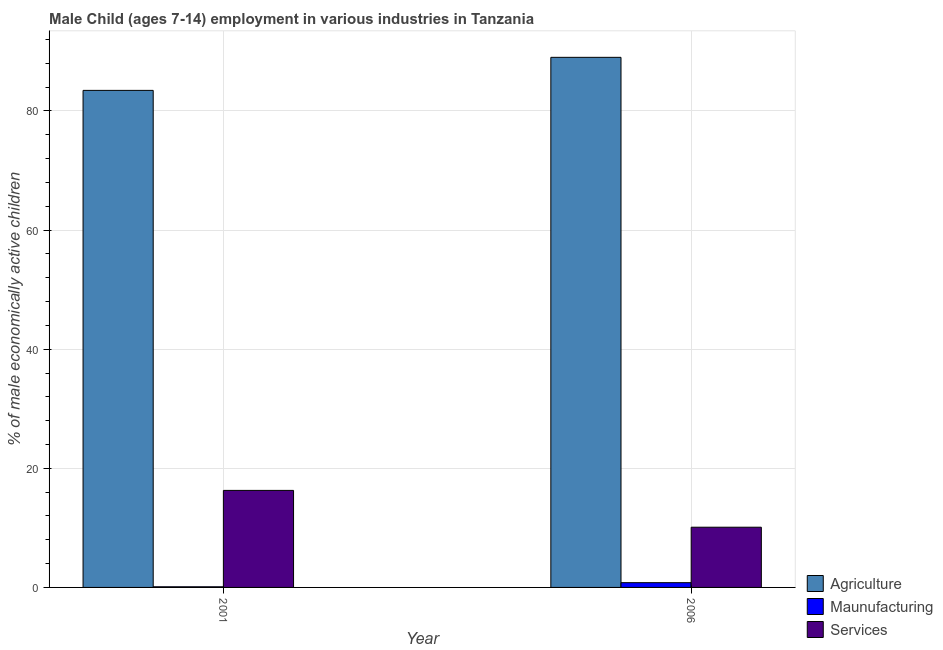How many groups of bars are there?
Your answer should be compact. 2. Are the number of bars per tick equal to the number of legend labels?
Offer a very short reply. Yes. How many bars are there on the 1st tick from the left?
Offer a terse response. 3. What is the label of the 2nd group of bars from the left?
Offer a very short reply. 2006. In how many cases, is the number of bars for a given year not equal to the number of legend labels?
Provide a short and direct response. 0. What is the percentage of economically active children in services in 2006?
Ensure brevity in your answer.  10.11. Across all years, what is the maximum percentage of economically active children in services?
Your answer should be compact. 16.29. Across all years, what is the minimum percentage of economically active children in services?
Your answer should be very brief. 10.11. In which year was the percentage of economically active children in services maximum?
Give a very brief answer. 2001. In which year was the percentage of economically active children in agriculture minimum?
Offer a very short reply. 2001. What is the total percentage of economically active children in agriculture in the graph?
Your answer should be very brief. 172.47. What is the difference between the percentage of economically active children in agriculture in 2001 and that in 2006?
Provide a succinct answer. -5.55. What is the difference between the percentage of economically active children in services in 2006 and the percentage of economically active children in manufacturing in 2001?
Your response must be concise. -6.18. What is the average percentage of economically active children in manufacturing per year?
Give a very brief answer. 0.45. In how many years, is the percentage of economically active children in services greater than 56 %?
Offer a terse response. 0. What is the ratio of the percentage of economically active children in agriculture in 2001 to that in 2006?
Your answer should be compact. 0.94. Is the percentage of economically active children in manufacturing in 2001 less than that in 2006?
Make the answer very short. Yes. What does the 3rd bar from the left in 2001 represents?
Provide a succinct answer. Services. What does the 2nd bar from the right in 2006 represents?
Keep it short and to the point. Maunufacturing. Is it the case that in every year, the sum of the percentage of economically active children in agriculture and percentage of economically active children in manufacturing is greater than the percentage of economically active children in services?
Provide a short and direct response. Yes. How many years are there in the graph?
Make the answer very short. 2. What is the difference between two consecutive major ticks on the Y-axis?
Give a very brief answer. 20. Does the graph contain any zero values?
Give a very brief answer. No. Does the graph contain grids?
Keep it short and to the point. Yes. How are the legend labels stacked?
Provide a short and direct response. Vertical. What is the title of the graph?
Offer a terse response. Male Child (ages 7-14) employment in various industries in Tanzania. Does "Taxes on goods and services" appear as one of the legend labels in the graph?
Ensure brevity in your answer.  No. What is the label or title of the X-axis?
Your answer should be very brief. Year. What is the label or title of the Y-axis?
Your answer should be very brief. % of male economically active children. What is the % of male economically active children in Agriculture in 2001?
Offer a very short reply. 83.46. What is the % of male economically active children of Maunufacturing in 2001?
Offer a very short reply. 0.11. What is the % of male economically active children in Services in 2001?
Offer a terse response. 16.29. What is the % of male economically active children in Agriculture in 2006?
Your answer should be very brief. 89.01. What is the % of male economically active children of Maunufacturing in 2006?
Offer a terse response. 0.8. What is the % of male economically active children in Services in 2006?
Give a very brief answer. 10.11. Across all years, what is the maximum % of male economically active children of Agriculture?
Offer a terse response. 89.01. Across all years, what is the maximum % of male economically active children of Maunufacturing?
Your response must be concise. 0.8. Across all years, what is the maximum % of male economically active children of Services?
Provide a succinct answer. 16.29. Across all years, what is the minimum % of male economically active children in Agriculture?
Your answer should be very brief. 83.46. Across all years, what is the minimum % of male economically active children in Maunufacturing?
Offer a terse response. 0.11. Across all years, what is the minimum % of male economically active children of Services?
Make the answer very short. 10.11. What is the total % of male economically active children in Agriculture in the graph?
Keep it short and to the point. 172.47. What is the total % of male economically active children in Maunufacturing in the graph?
Provide a short and direct response. 0.91. What is the total % of male economically active children in Services in the graph?
Your answer should be compact. 26.4. What is the difference between the % of male economically active children of Agriculture in 2001 and that in 2006?
Provide a succinct answer. -5.55. What is the difference between the % of male economically active children of Maunufacturing in 2001 and that in 2006?
Your answer should be very brief. -0.69. What is the difference between the % of male economically active children in Services in 2001 and that in 2006?
Keep it short and to the point. 6.18. What is the difference between the % of male economically active children in Agriculture in 2001 and the % of male economically active children in Maunufacturing in 2006?
Your answer should be compact. 82.66. What is the difference between the % of male economically active children in Agriculture in 2001 and the % of male economically active children in Services in 2006?
Your answer should be very brief. 73.35. What is the difference between the % of male economically active children of Maunufacturing in 2001 and the % of male economically active children of Services in 2006?
Provide a short and direct response. -10. What is the average % of male economically active children of Agriculture per year?
Offer a terse response. 86.23. What is the average % of male economically active children in Maunufacturing per year?
Make the answer very short. 0.45. What is the average % of male economically active children in Services per year?
Your answer should be compact. 13.2. In the year 2001, what is the difference between the % of male economically active children in Agriculture and % of male economically active children in Maunufacturing?
Give a very brief answer. 83.35. In the year 2001, what is the difference between the % of male economically active children of Agriculture and % of male economically active children of Services?
Your answer should be very brief. 67.17. In the year 2001, what is the difference between the % of male economically active children of Maunufacturing and % of male economically active children of Services?
Your response must be concise. -16.18. In the year 2006, what is the difference between the % of male economically active children of Agriculture and % of male economically active children of Maunufacturing?
Provide a succinct answer. 88.21. In the year 2006, what is the difference between the % of male economically active children in Agriculture and % of male economically active children in Services?
Your response must be concise. 78.9. In the year 2006, what is the difference between the % of male economically active children in Maunufacturing and % of male economically active children in Services?
Keep it short and to the point. -9.31. What is the ratio of the % of male economically active children of Agriculture in 2001 to that in 2006?
Provide a short and direct response. 0.94. What is the ratio of the % of male economically active children in Maunufacturing in 2001 to that in 2006?
Your response must be concise. 0.13. What is the ratio of the % of male economically active children of Services in 2001 to that in 2006?
Make the answer very short. 1.61. What is the difference between the highest and the second highest % of male economically active children in Agriculture?
Offer a very short reply. 5.55. What is the difference between the highest and the second highest % of male economically active children of Maunufacturing?
Provide a short and direct response. 0.69. What is the difference between the highest and the second highest % of male economically active children in Services?
Offer a very short reply. 6.18. What is the difference between the highest and the lowest % of male economically active children of Agriculture?
Offer a very short reply. 5.55. What is the difference between the highest and the lowest % of male economically active children in Maunufacturing?
Give a very brief answer. 0.69. What is the difference between the highest and the lowest % of male economically active children in Services?
Offer a very short reply. 6.18. 